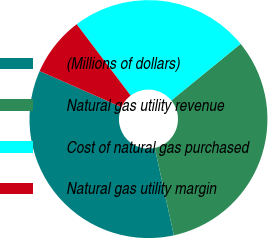<chart> <loc_0><loc_0><loc_500><loc_500><pie_chart><fcel>(Millions of dollars)<fcel>Natural gas utility revenue<fcel>Cost of natural gas purchased<fcel>Natural gas utility margin<nl><fcel>35.05%<fcel>32.47%<fcel>24.41%<fcel>8.07%<nl></chart> 